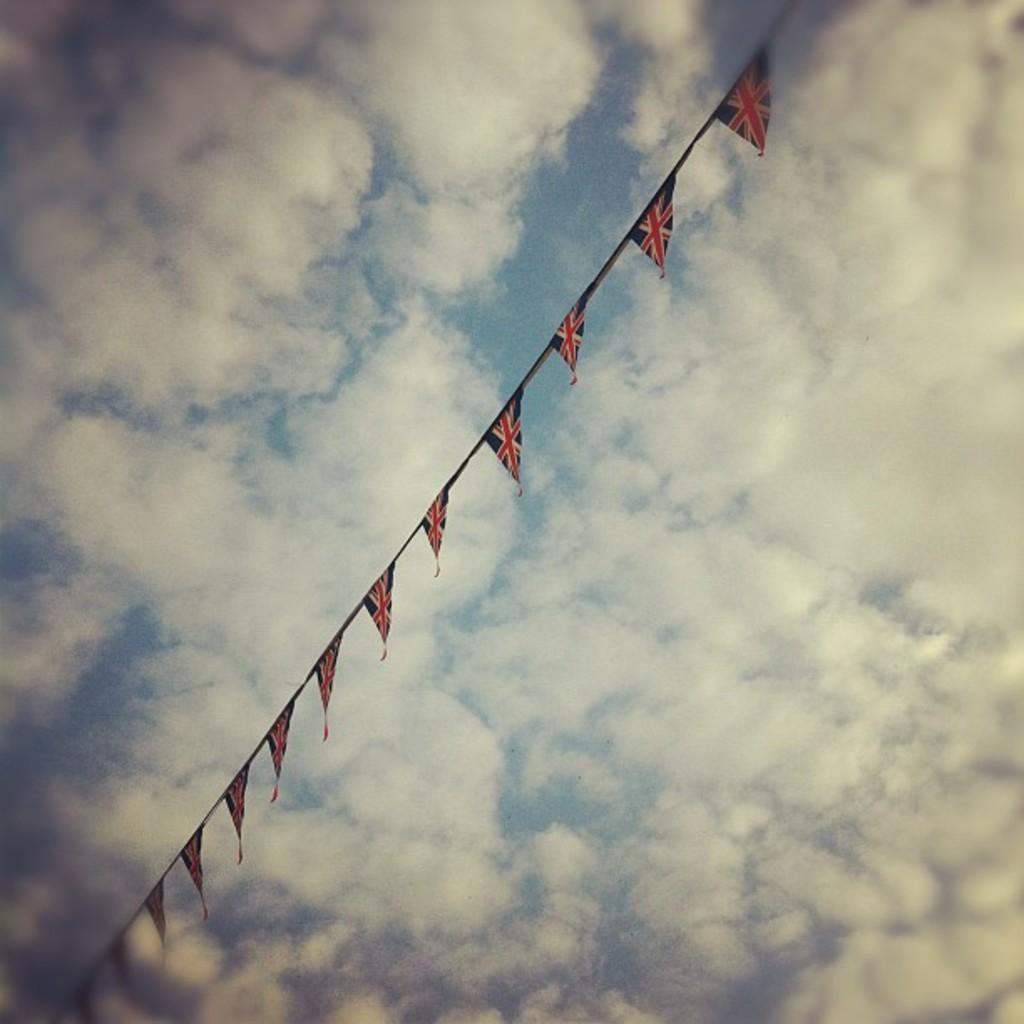Please provide a concise description of this image. In this image we can see a rope with flags. In the background there is sky with clouds. 